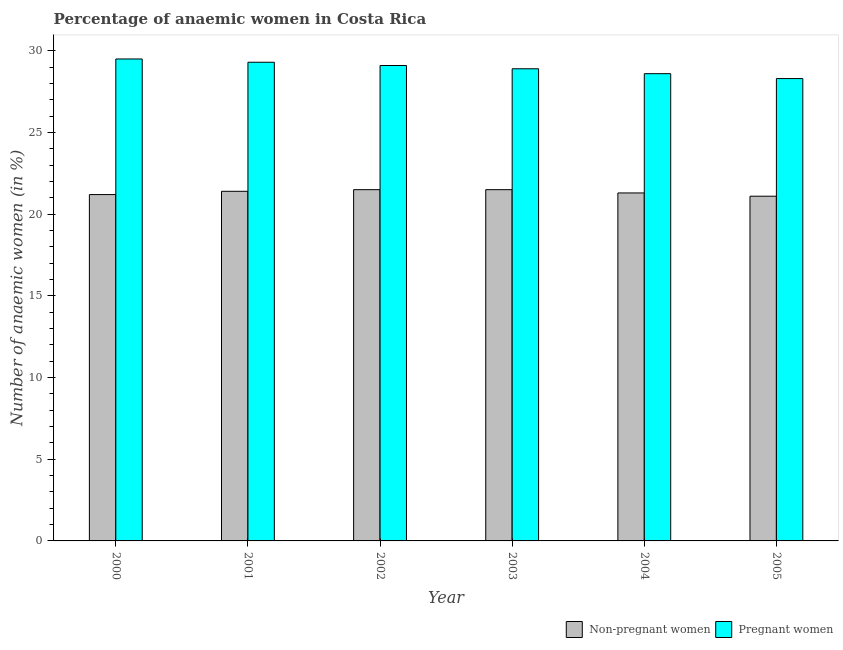How many different coloured bars are there?
Provide a short and direct response. 2. Are the number of bars on each tick of the X-axis equal?
Keep it short and to the point. Yes. How many bars are there on the 4th tick from the right?
Offer a very short reply. 2. What is the label of the 2nd group of bars from the left?
Your response must be concise. 2001. In how many cases, is the number of bars for a given year not equal to the number of legend labels?
Ensure brevity in your answer.  0. What is the percentage of pregnant anaemic women in 2001?
Give a very brief answer. 29.3. Across all years, what is the maximum percentage of pregnant anaemic women?
Offer a very short reply. 29.5. Across all years, what is the minimum percentage of pregnant anaemic women?
Give a very brief answer. 28.3. In which year was the percentage of pregnant anaemic women maximum?
Make the answer very short. 2000. In which year was the percentage of non-pregnant anaemic women minimum?
Give a very brief answer. 2005. What is the total percentage of non-pregnant anaemic women in the graph?
Keep it short and to the point. 128. What is the difference between the percentage of pregnant anaemic women in 2002 and that in 2003?
Offer a terse response. 0.2. What is the difference between the percentage of non-pregnant anaemic women in 2003 and the percentage of pregnant anaemic women in 2004?
Offer a very short reply. 0.2. What is the average percentage of pregnant anaemic women per year?
Ensure brevity in your answer.  28.95. Is the percentage of non-pregnant anaemic women in 2001 less than that in 2002?
Provide a short and direct response. Yes. What is the difference between the highest and the second highest percentage of pregnant anaemic women?
Provide a short and direct response. 0.2. What is the difference between the highest and the lowest percentage of pregnant anaemic women?
Your answer should be very brief. 1.2. In how many years, is the percentage of pregnant anaemic women greater than the average percentage of pregnant anaemic women taken over all years?
Ensure brevity in your answer.  3. Is the sum of the percentage of non-pregnant anaemic women in 2000 and 2002 greater than the maximum percentage of pregnant anaemic women across all years?
Provide a short and direct response. Yes. What does the 2nd bar from the left in 2001 represents?
Offer a terse response. Pregnant women. What does the 2nd bar from the right in 2005 represents?
Ensure brevity in your answer.  Non-pregnant women. How many bars are there?
Offer a terse response. 12. Are all the bars in the graph horizontal?
Give a very brief answer. No. How many years are there in the graph?
Give a very brief answer. 6. How many legend labels are there?
Give a very brief answer. 2. How are the legend labels stacked?
Keep it short and to the point. Horizontal. What is the title of the graph?
Keep it short and to the point. Percentage of anaemic women in Costa Rica. Does "Taxes on profits and capital gains" appear as one of the legend labels in the graph?
Give a very brief answer. No. What is the label or title of the X-axis?
Provide a short and direct response. Year. What is the label or title of the Y-axis?
Keep it short and to the point. Number of anaemic women (in %). What is the Number of anaemic women (in %) in Non-pregnant women in 2000?
Keep it short and to the point. 21.2. What is the Number of anaemic women (in %) of Pregnant women in 2000?
Make the answer very short. 29.5. What is the Number of anaemic women (in %) of Non-pregnant women in 2001?
Provide a succinct answer. 21.4. What is the Number of anaemic women (in %) in Pregnant women in 2001?
Provide a short and direct response. 29.3. What is the Number of anaemic women (in %) in Non-pregnant women in 2002?
Offer a very short reply. 21.5. What is the Number of anaemic women (in %) of Pregnant women in 2002?
Ensure brevity in your answer.  29.1. What is the Number of anaemic women (in %) of Non-pregnant women in 2003?
Ensure brevity in your answer.  21.5. What is the Number of anaemic women (in %) in Pregnant women in 2003?
Provide a succinct answer. 28.9. What is the Number of anaemic women (in %) of Non-pregnant women in 2004?
Provide a succinct answer. 21.3. What is the Number of anaemic women (in %) of Pregnant women in 2004?
Offer a very short reply. 28.6. What is the Number of anaemic women (in %) in Non-pregnant women in 2005?
Give a very brief answer. 21.1. What is the Number of anaemic women (in %) of Pregnant women in 2005?
Make the answer very short. 28.3. Across all years, what is the maximum Number of anaemic women (in %) of Pregnant women?
Your answer should be very brief. 29.5. Across all years, what is the minimum Number of anaemic women (in %) in Non-pregnant women?
Offer a terse response. 21.1. Across all years, what is the minimum Number of anaemic women (in %) of Pregnant women?
Make the answer very short. 28.3. What is the total Number of anaemic women (in %) of Non-pregnant women in the graph?
Offer a terse response. 128. What is the total Number of anaemic women (in %) of Pregnant women in the graph?
Keep it short and to the point. 173.7. What is the difference between the Number of anaemic women (in %) in Non-pregnant women in 2000 and that in 2001?
Give a very brief answer. -0.2. What is the difference between the Number of anaemic women (in %) of Non-pregnant women in 2000 and that in 2003?
Provide a succinct answer. -0.3. What is the difference between the Number of anaemic women (in %) in Non-pregnant women in 2001 and that in 2002?
Offer a terse response. -0.1. What is the difference between the Number of anaemic women (in %) in Non-pregnant women in 2001 and that in 2003?
Keep it short and to the point. -0.1. What is the difference between the Number of anaemic women (in %) in Pregnant women in 2001 and that in 2004?
Ensure brevity in your answer.  0.7. What is the difference between the Number of anaemic women (in %) of Pregnant women in 2001 and that in 2005?
Offer a very short reply. 1. What is the difference between the Number of anaemic women (in %) of Non-pregnant women in 2002 and that in 2003?
Your response must be concise. 0. What is the difference between the Number of anaemic women (in %) in Pregnant women in 2002 and that in 2003?
Your answer should be compact. 0.2. What is the difference between the Number of anaemic women (in %) of Pregnant women in 2002 and that in 2004?
Offer a terse response. 0.5. What is the difference between the Number of anaemic women (in %) of Pregnant women in 2003 and that in 2004?
Your response must be concise. 0.3. What is the difference between the Number of anaemic women (in %) in Pregnant women in 2003 and that in 2005?
Offer a terse response. 0.6. What is the difference between the Number of anaemic women (in %) of Non-pregnant women in 2004 and that in 2005?
Your answer should be compact. 0.2. What is the difference between the Number of anaemic women (in %) in Non-pregnant women in 2000 and the Number of anaemic women (in %) in Pregnant women in 2004?
Offer a terse response. -7.4. What is the difference between the Number of anaemic women (in %) of Non-pregnant women in 2000 and the Number of anaemic women (in %) of Pregnant women in 2005?
Provide a succinct answer. -7.1. What is the difference between the Number of anaemic women (in %) in Non-pregnant women in 2001 and the Number of anaemic women (in %) in Pregnant women in 2003?
Provide a succinct answer. -7.5. What is the difference between the Number of anaemic women (in %) of Non-pregnant women in 2001 and the Number of anaemic women (in %) of Pregnant women in 2005?
Your answer should be very brief. -6.9. What is the difference between the Number of anaemic women (in %) in Non-pregnant women in 2002 and the Number of anaemic women (in %) in Pregnant women in 2005?
Offer a terse response. -6.8. What is the difference between the Number of anaemic women (in %) in Non-pregnant women in 2003 and the Number of anaemic women (in %) in Pregnant women in 2004?
Offer a very short reply. -7.1. What is the average Number of anaemic women (in %) in Non-pregnant women per year?
Provide a succinct answer. 21.33. What is the average Number of anaemic women (in %) of Pregnant women per year?
Provide a short and direct response. 28.95. In the year 2001, what is the difference between the Number of anaemic women (in %) of Non-pregnant women and Number of anaemic women (in %) of Pregnant women?
Ensure brevity in your answer.  -7.9. In the year 2003, what is the difference between the Number of anaemic women (in %) of Non-pregnant women and Number of anaemic women (in %) of Pregnant women?
Make the answer very short. -7.4. In the year 2004, what is the difference between the Number of anaemic women (in %) in Non-pregnant women and Number of anaemic women (in %) in Pregnant women?
Your response must be concise. -7.3. What is the ratio of the Number of anaemic women (in %) of Non-pregnant women in 2000 to that in 2001?
Offer a terse response. 0.99. What is the ratio of the Number of anaemic women (in %) in Pregnant women in 2000 to that in 2001?
Give a very brief answer. 1.01. What is the ratio of the Number of anaemic women (in %) of Non-pregnant women in 2000 to that in 2002?
Your answer should be very brief. 0.99. What is the ratio of the Number of anaemic women (in %) in Pregnant women in 2000 to that in 2002?
Provide a succinct answer. 1.01. What is the ratio of the Number of anaemic women (in %) of Non-pregnant women in 2000 to that in 2003?
Offer a terse response. 0.99. What is the ratio of the Number of anaemic women (in %) of Pregnant women in 2000 to that in 2003?
Offer a very short reply. 1.02. What is the ratio of the Number of anaemic women (in %) of Non-pregnant women in 2000 to that in 2004?
Offer a very short reply. 1. What is the ratio of the Number of anaemic women (in %) of Pregnant women in 2000 to that in 2004?
Make the answer very short. 1.03. What is the ratio of the Number of anaemic women (in %) of Pregnant women in 2000 to that in 2005?
Offer a very short reply. 1.04. What is the ratio of the Number of anaemic women (in %) in Non-pregnant women in 2001 to that in 2003?
Your answer should be compact. 1. What is the ratio of the Number of anaemic women (in %) in Pregnant women in 2001 to that in 2003?
Keep it short and to the point. 1.01. What is the ratio of the Number of anaemic women (in %) in Non-pregnant women in 2001 to that in 2004?
Keep it short and to the point. 1. What is the ratio of the Number of anaemic women (in %) in Pregnant women in 2001 to that in 2004?
Your answer should be very brief. 1.02. What is the ratio of the Number of anaemic women (in %) of Non-pregnant women in 2001 to that in 2005?
Your answer should be compact. 1.01. What is the ratio of the Number of anaemic women (in %) of Pregnant women in 2001 to that in 2005?
Provide a succinct answer. 1.04. What is the ratio of the Number of anaemic women (in %) of Non-pregnant women in 2002 to that in 2004?
Provide a succinct answer. 1.01. What is the ratio of the Number of anaemic women (in %) of Pregnant women in 2002 to that in 2004?
Offer a very short reply. 1.02. What is the ratio of the Number of anaemic women (in %) of Pregnant women in 2002 to that in 2005?
Offer a terse response. 1.03. What is the ratio of the Number of anaemic women (in %) of Non-pregnant women in 2003 to that in 2004?
Offer a terse response. 1.01. What is the ratio of the Number of anaemic women (in %) in Pregnant women in 2003 to that in 2004?
Your response must be concise. 1.01. What is the ratio of the Number of anaemic women (in %) of Pregnant women in 2003 to that in 2005?
Your response must be concise. 1.02. What is the ratio of the Number of anaemic women (in %) in Non-pregnant women in 2004 to that in 2005?
Make the answer very short. 1.01. What is the ratio of the Number of anaemic women (in %) of Pregnant women in 2004 to that in 2005?
Ensure brevity in your answer.  1.01. What is the difference between the highest and the lowest Number of anaemic women (in %) of Pregnant women?
Offer a terse response. 1.2. 